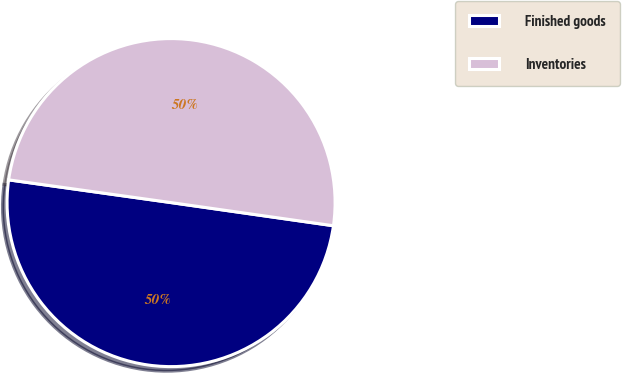Convert chart to OTSL. <chart><loc_0><loc_0><loc_500><loc_500><pie_chart><fcel>Finished goods<fcel>Inventories<nl><fcel>49.96%<fcel>50.04%<nl></chart> 